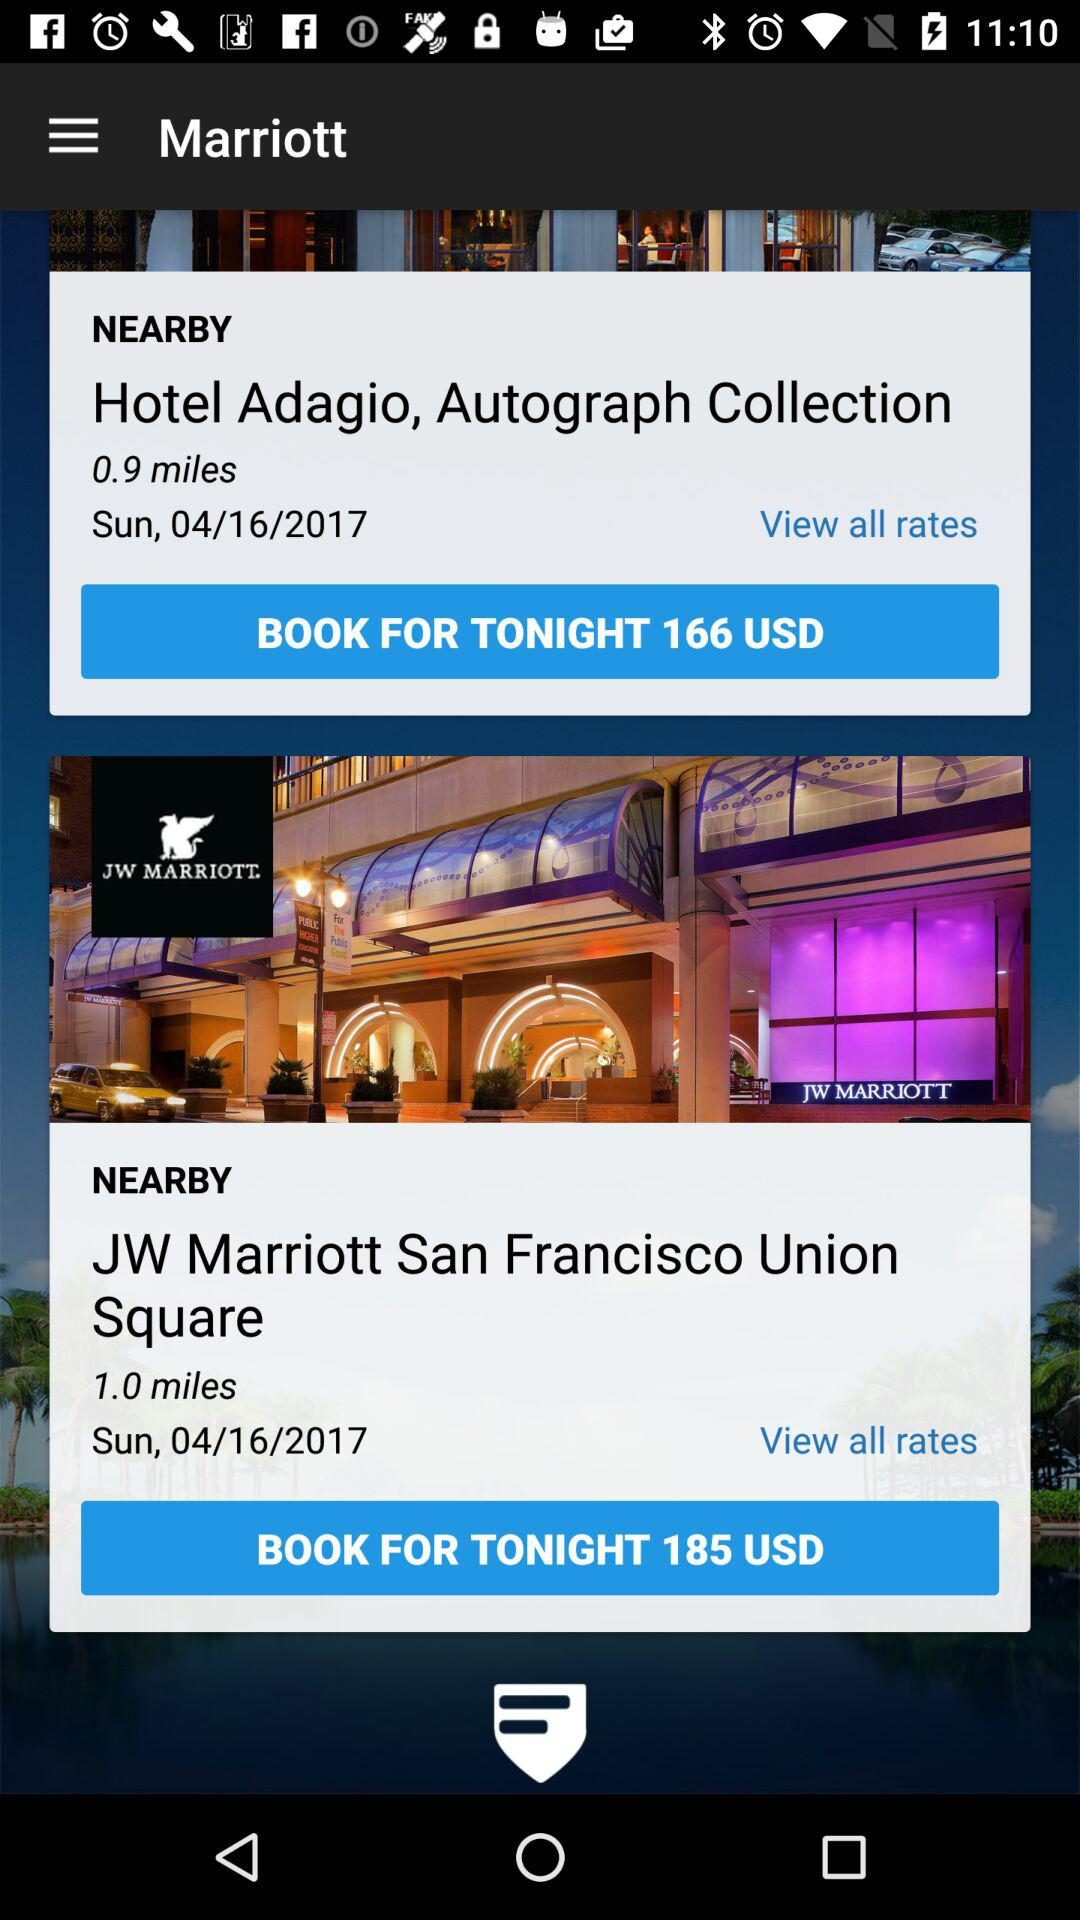What is the booking price of a room at the "JW Marriott"? The booking price is 185 USD. 